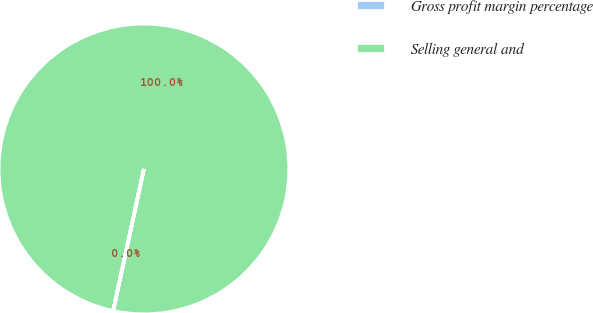Convert chart to OTSL. <chart><loc_0><loc_0><loc_500><loc_500><pie_chart><fcel>Gross profit margin percentage<fcel>Selling general and<nl><fcel>0.01%<fcel>99.99%<nl></chart> 